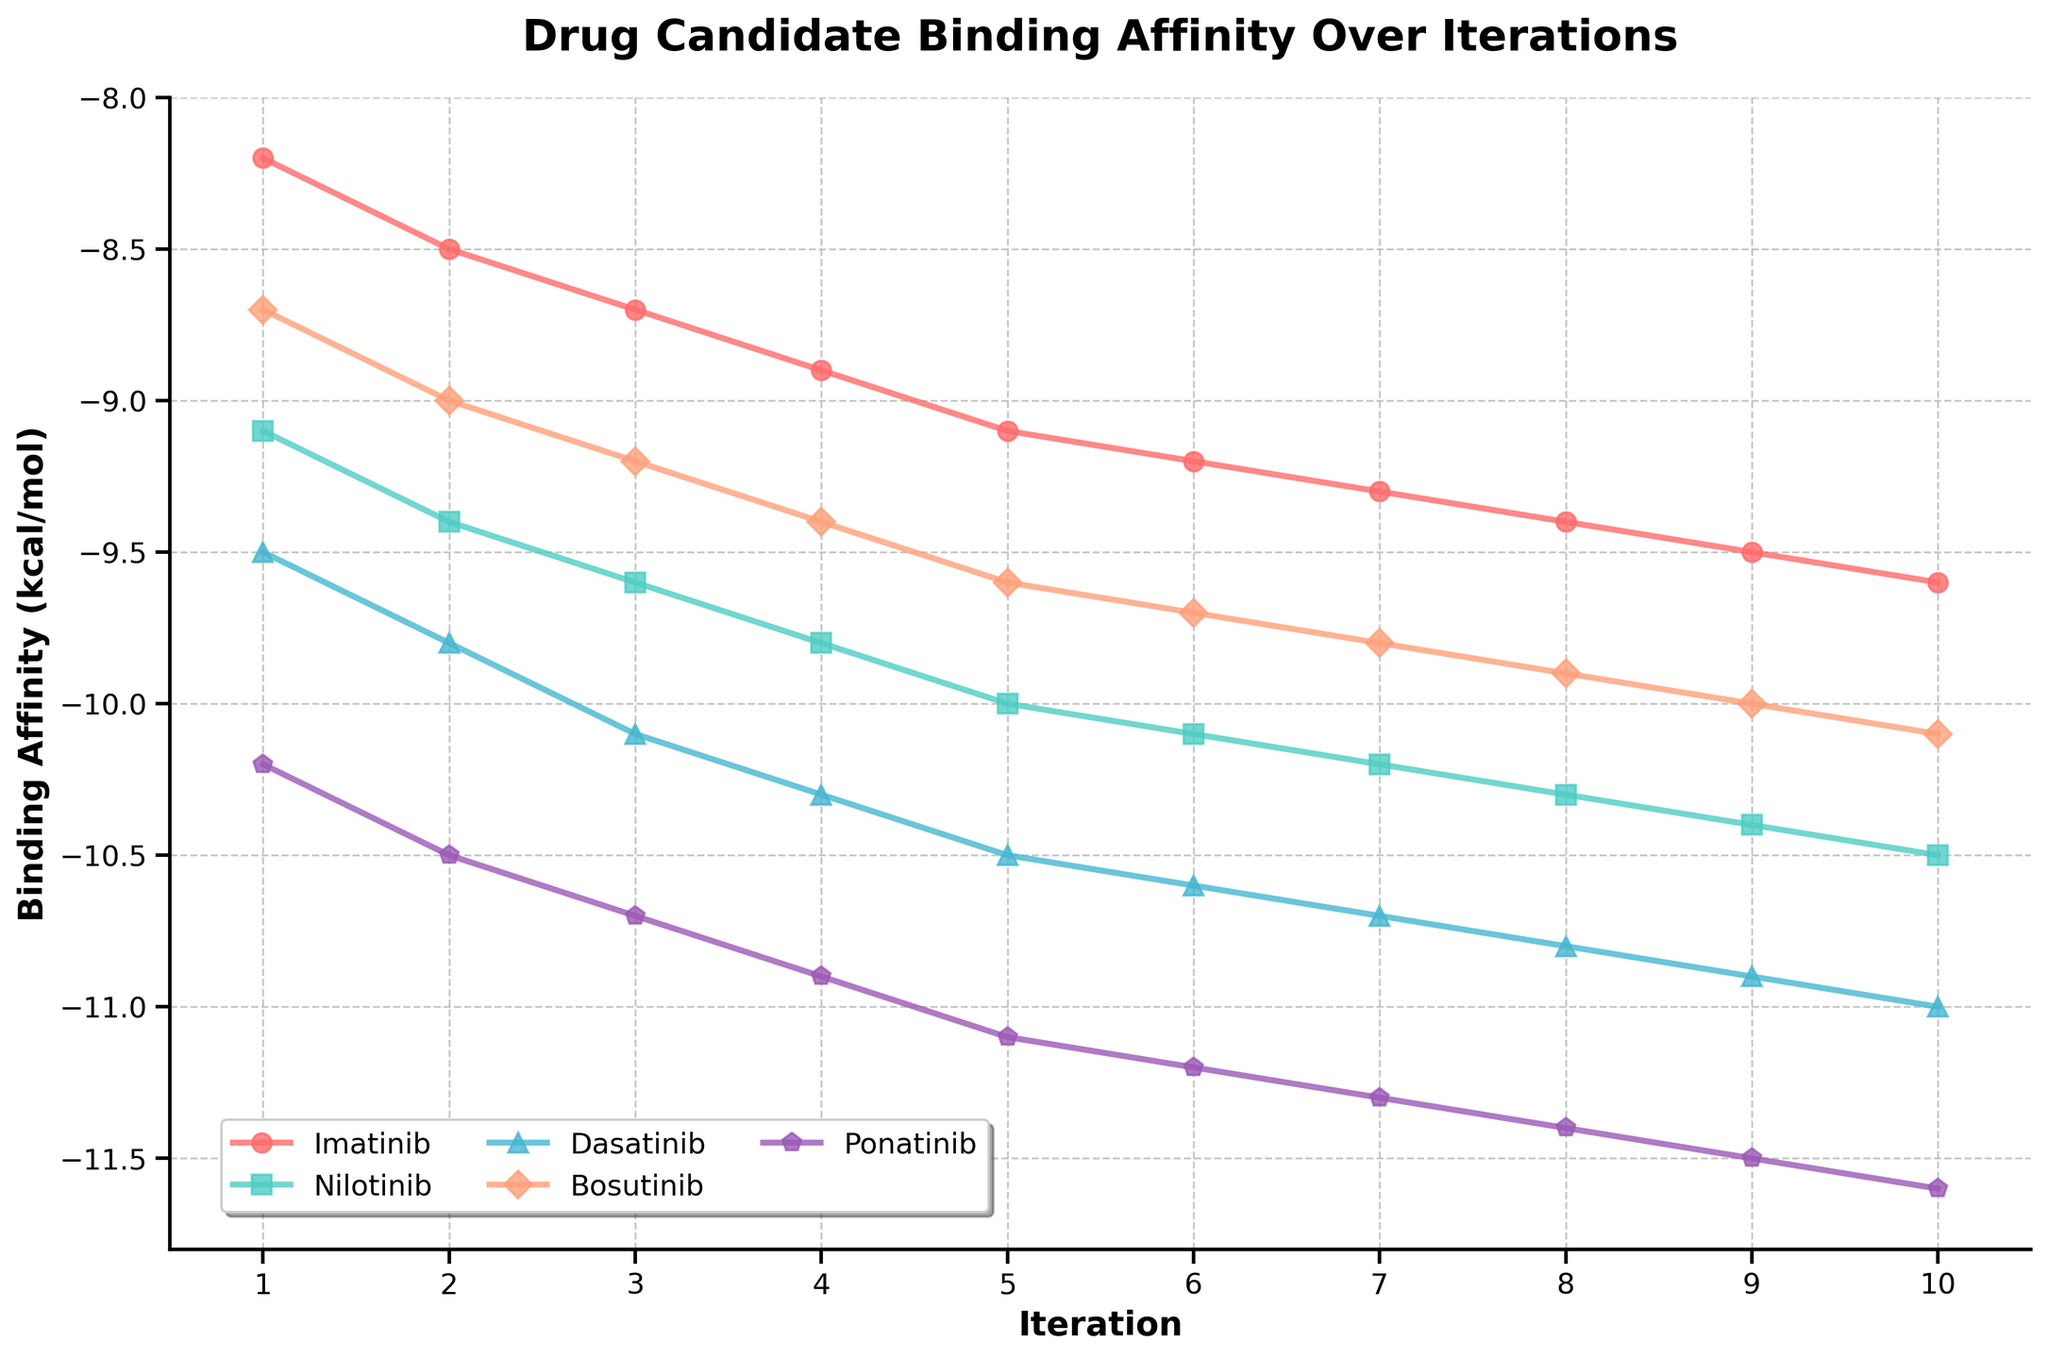What is the overall trend of Ponatinib's binding affinity over the iterations? The line for Ponatinib shows a continuous decrease in binding affinity values from -10.2 at iteration 1 to -11.6 at iteration 10. This suggests that Ponatinib’s binding affinity improves consistently over the iterations (binding affinity is more negative, better binding).
Answer: Continuous improvement What is the difference between the binding affinities of Dasatinib and Bosutinib at iteration 5? At iteration 5, the binding affinity of Dasatinib is -10.5, and for Bosutinib, it is -9.6. The difference is calculated as -10.5 - (-9.6) = -0.9.
Answer: -0.9 At which iteration does Nilotinib first show a binding affinity better (more negative) than -10.0 kcal/mol? The binding affinity of Nilotinib is better than -10.0 kcal/mol at iteration 5 and beyond. Therefore, the first occurrence is at iteration 5.
Answer: Iteration 5 Among the five drug candidates, which one shows the most improvement in binding affinity from iteration 1 to iteration 10? Calculate the improvement by subtracting the binding affinity at iteration 1 from the binding affinity at iteration 10 for each drug. The most improvement is shown by Ponatinib: (-11.6) - (-10.2) = -1.4. Therefore, Ponatinib shows the most improvement.
Answer: Ponatinib Which drug candidate has the least binding affinity (least negative value) at iteration 7? At iteration 7, the binding affinities for the drug candidates are: Imatinib (-9.3), Nilotinib (-10.2), Dasatinib (-10.7), Bosutinib (-9.8), and Ponatinib (-11.3). The least binding affinity (least negative value) is Imatinib -9.3.
Answer: Imatinib Compare the binding affinity trends of Imatinib and Dasatinib. Are their trends similar or different? Both Imatinib and Dasatinib show a decreasing trend in their binding affinities (more negative), indicating improvement. However, Dasatinib shows a steeper and more significant decline compared to Imatinib, meaning its binding affinity improves at a faster rate.
Answer: Different What is the average binding affinity for Bosutinib over the first three iterations? The binding affinities for Bosutinib over the first three iterations are -8.7, -9.0, and -9.2. Their sum is -8.7 + (-9.0) + (-9.2) = -26.9. The average is -26.9/3 = -8.97.
Answer: -8.97 Which iteration shows the smallest rate of change in binding affinity for Nilotinib compared to its previous iteration? Calculate the rate of change for Nilotinib: 
(2-1: -9.4 - (-9.1) = -0.3), 
(3-2: -9.6 - (-9.4) = -0.2), 
(4-3: -9.8 - (-9.6) = -0.2), 
(5-4: -10.0 - (-9.8) = -0.2), 
(6-5: -10.1 - (-10.0) = -0.1), 
(7-6: -10.2 - (-10.1) = -0.1), 
(8-7: -10.3 - (-10.2) = -0.1), 
(9-8: -10.4 - (-10.3) = -0.1), 
(10-9: -10.5 - (-10.4) = -0.1). The smallest rate of change, -0.1, occurs from iteration 5 to iteration 6.
Answer: Iteration 6 